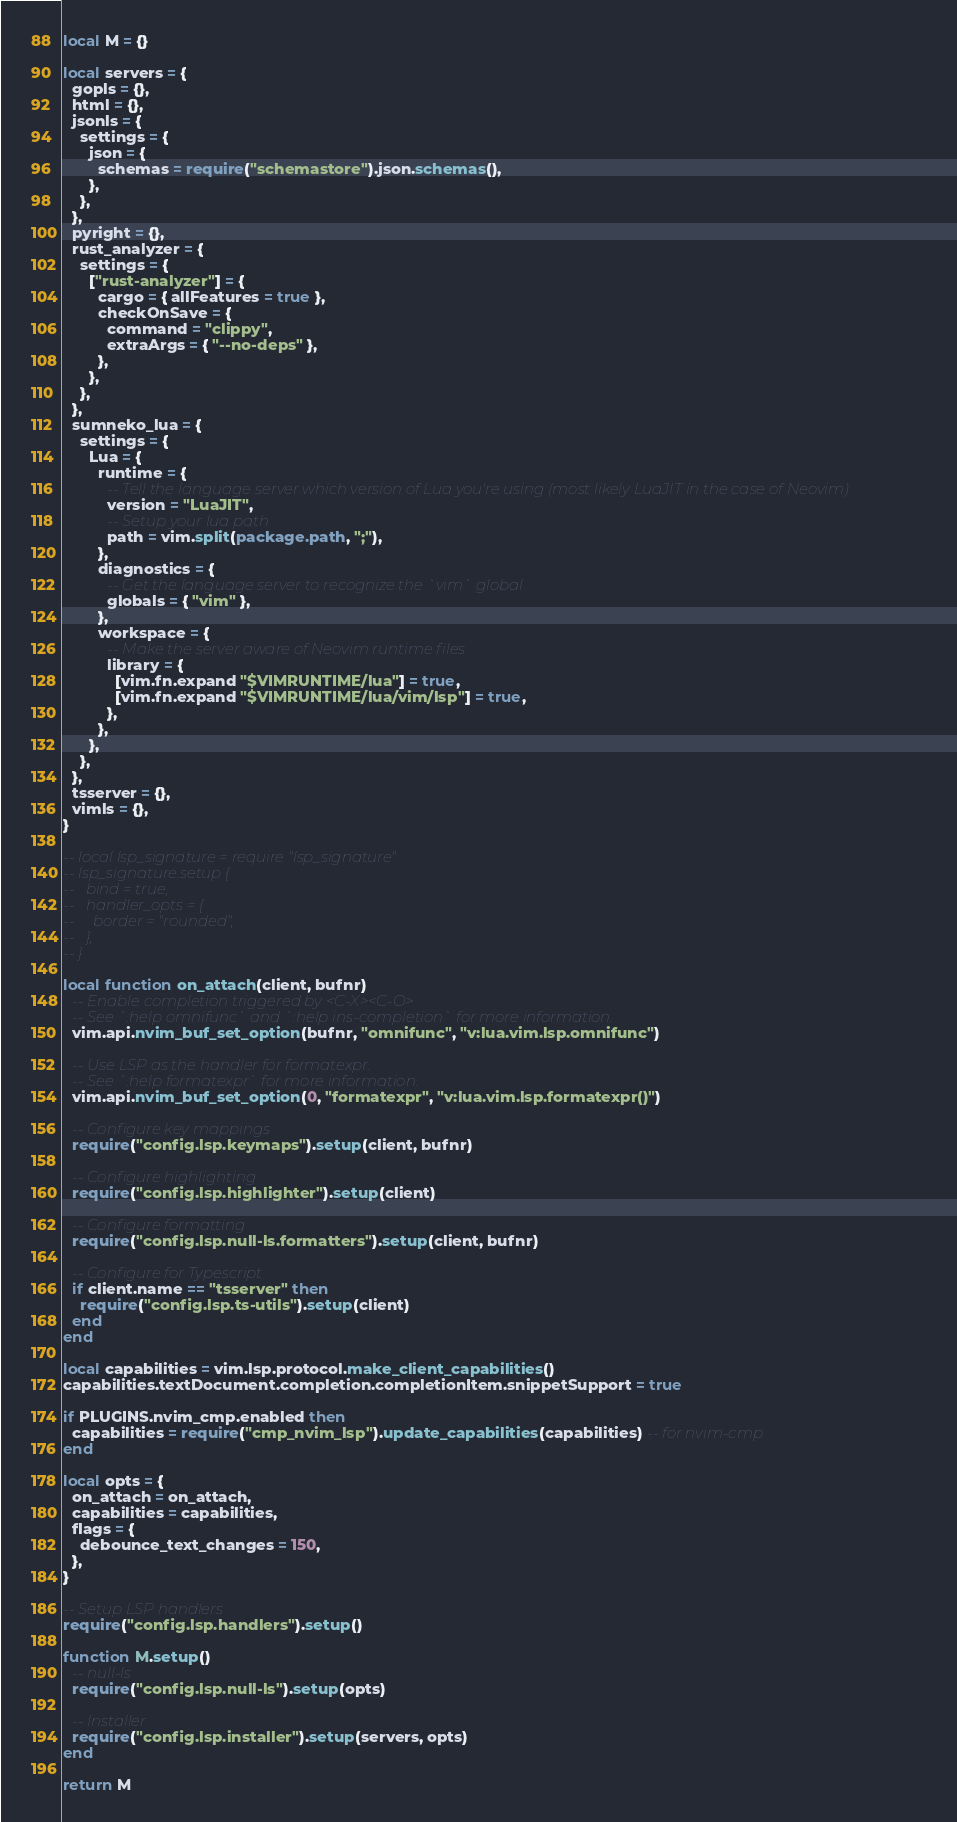Convert code to text. <code><loc_0><loc_0><loc_500><loc_500><_Lua_>local M = {}

local servers = {
  gopls = {},
  html = {},
  jsonls = {
    settings = {
      json = {
        schemas = require("schemastore").json.schemas(),
      },
    },
  },
  pyright = {},
  rust_analyzer = {
    settings = {
      ["rust-analyzer"] = {
        cargo = { allFeatures = true },
        checkOnSave = {
          command = "clippy",
          extraArgs = { "--no-deps" },
        },
      },
    },
  },
  sumneko_lua = {
    settings = {
      Lua = {
        runtime = {
          -- Tell the language server which version of Lua you're using (most likely LuaJIT in the case of Neovim)
          version = "LuaJIT",
          -- Setup your lua path
          path = vim.split(package.path, ";"),
        },
        diagnostics = {
          -- Get the language server to recognize the `vim` global
          globals = { "vim" },
        },
        workspace = {
          -- Make the server aware of Neovim runtime files
          library = {
            [vim.fn.expand "$VIMRUNTIME/lua"] = true,
            [vim.fn.expand "$VIMRUNTIME/lua/vim/lsp"] = true,
          },
        },
      },
    },
  },
  tsserver = {},
  vimls = {},
}

-- local lsp_signature = require "lsp_signature"
-- lsp_signature.setup {
--   bind = true,
--   handler_opts = {
--     border = "rounded",
--   },
-- }

local function on_attach(client, bufnr)
  -- Enable completion triggered by <C-X><C-O>
  -- See `:help omnifunc` and `:help ins-completion` for more information.
  vim.api.nvim_buf_set_option(bufnr, "omnifunc", "v:lua.vim.lsp.omnifunc")

  -- Use LSP as the handler for formatexpr.
  -- See `:help formatexpr` for more information.
  vim.api.nvim_buf_set_option(0, "formatexpr", "v:lua.vim.lsp.formatexpr()")

  -- Configure key mappings
  require("config.lsp.keymaps").setup(client, bufnr)

  -- Configure highlighting
  require("config.lsp.highlighter").setup(client)

  -- Configure formatting
  require("config.lsp.null-ls.formatters").setup(client, bufnr)

  -- Configure for Typescript
  if client.name == "tsserver" then
    require("config.lsp.ts-utils").setup(client)
  end
end

local capabilities = vim.lsp.protocol.make_client_capabilities()
capabilities.textDocument.completion.completionItem.snippetSupport = true

if PLUGINS.nvim_cmp.enabled then
  capabilities = require("cmp_nvim_lsp").update_capabilities(capabilities) -- for nvim-cmp
end

local opts = {
  on_attach = on_attach,
  capabilities = capabilities,
  flags = {
    debounce_text_changes = 150,
  },
}

-- Setup LSP handlers
require("config.lsp.handlers").setup()

function M.setup()
  -- null-ls
  require("config.lsp.null-ls").setup(opts)

  -- Installer
  require("config.lsp.installer").setup(servers, opts)
end

return M
</code> 